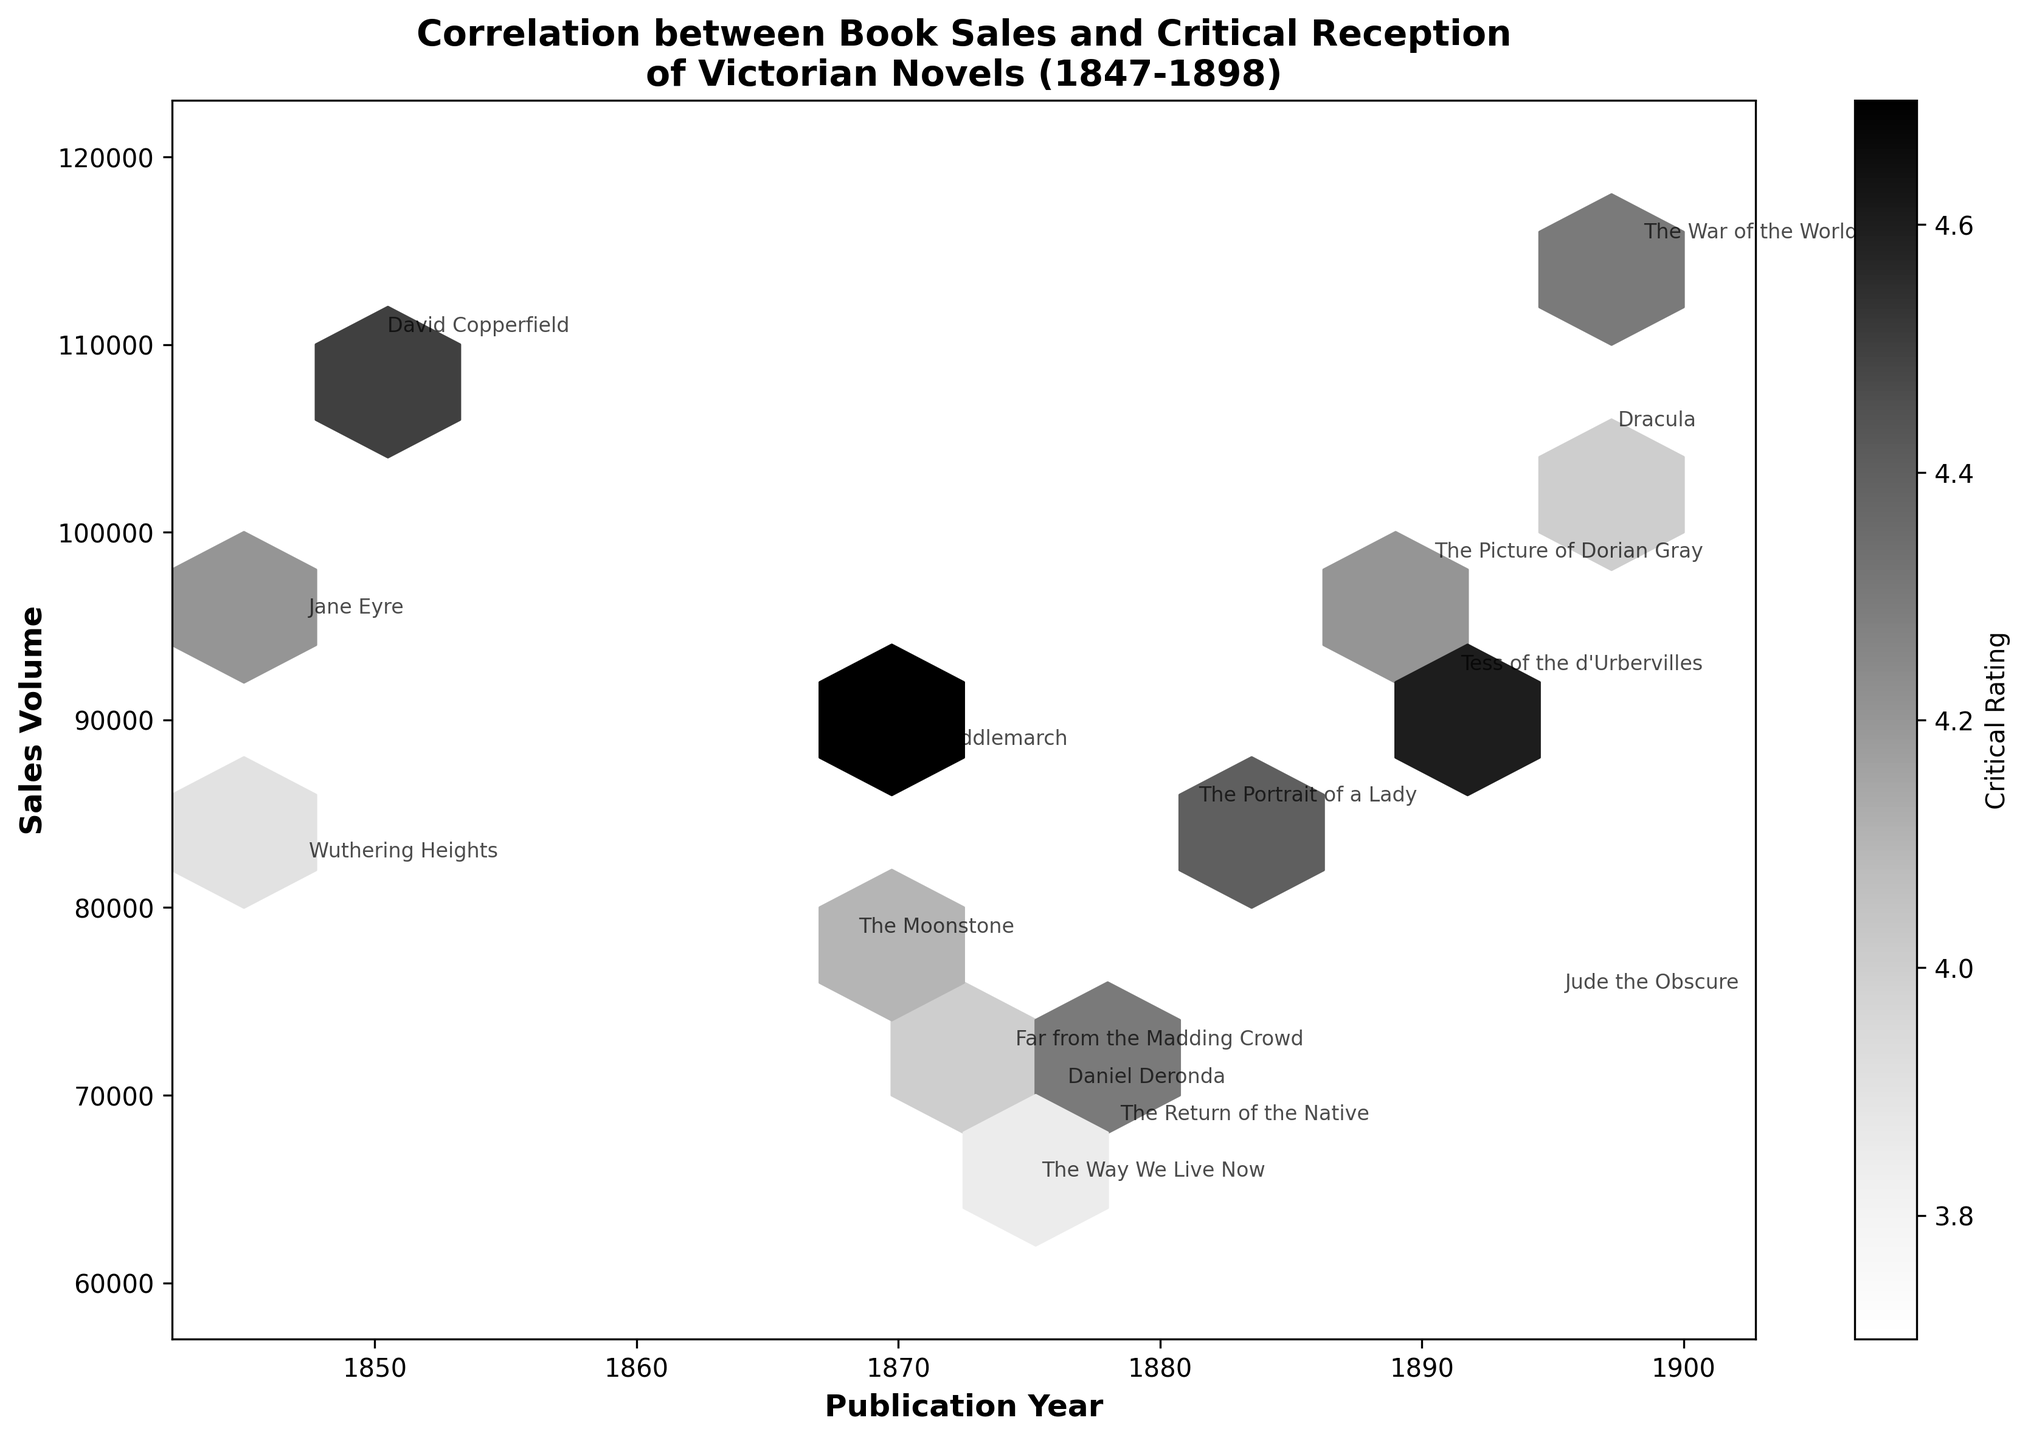What is the title of the plot? The title is usually located at the top center of the plot. From there, we can read that the title is "Correlation between Book Sales and Critical Reception of Victorian Novels (1847-1898)"
Answer: Correlation between Book Sales and Critical Reception of Victorian Novels (1847-1898) Which years are included on the x-axis? The x-axis label can be read to provide a range of years. The figure shows data spanning from 1847 to 1898
Answer: 1847-1898 What is the range of sales volume on the y-axis? By examining the y-axis, one can see that it ranges from 60,000 to 120,000 sales volume
Answer: 60,000-120,000 How many books are marked with text annotations on the plot? By counting the visible book titles annotated around the data points, one finds there are 15 annotations
Answer: 15 Which year had the highest recorded sales volume? By looking at the highest point along the y-axis and matching it to the corresponding publication year on the x-axis, it is 1898 with a sales volume of 115,000 (The War of the Worlds by H.G. Wells)
Answer: 1898 Do more recent books have higher critical ratings on average? By visually comparing the color of hexagons in the later years to those in the earlier years, one can see more darker hexagons (indicating higher critical ratings) towards the later years
Answer: Yes Which book has the highest critical rating and what is its rating? Looking at the text annotations and matching the darkest hexagon to the book title, we see that "Middlemarch" by George Eliot in 1871 has the highest critical rating of 4.7
Answer: Middlemarch, 4.7 Are there any years where sales volume exceeds 100,000? By examining the y-axis where sales volume surpasses 100,000 and finding the corresponding years, we see years marked as 1850, 1898, and 1897 with such volumes
Answer: Yes, in 1850, 1897, 1898 What observation can be made about books published in the 1840s concerning their critical ratings? By looking at the hexagons and the annotated books in the 1840s (Jane Eyre and Wuthering Heights), we notice that they have moderate critical ratings lighter in shade
Answer: Middle ratings Which author has multiple books plotted and how do their sales volumes compare? By looking at text annotations for repeating author names and noting their sales volumes, Thomas Hardy has multiple books with varied sales from 68,000 to 92,000
Answer: Thomas Hardy, varied sales between 68,000 to 92,000 